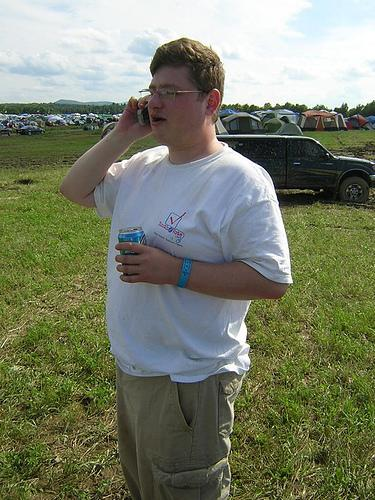What is his hairstyle? short 